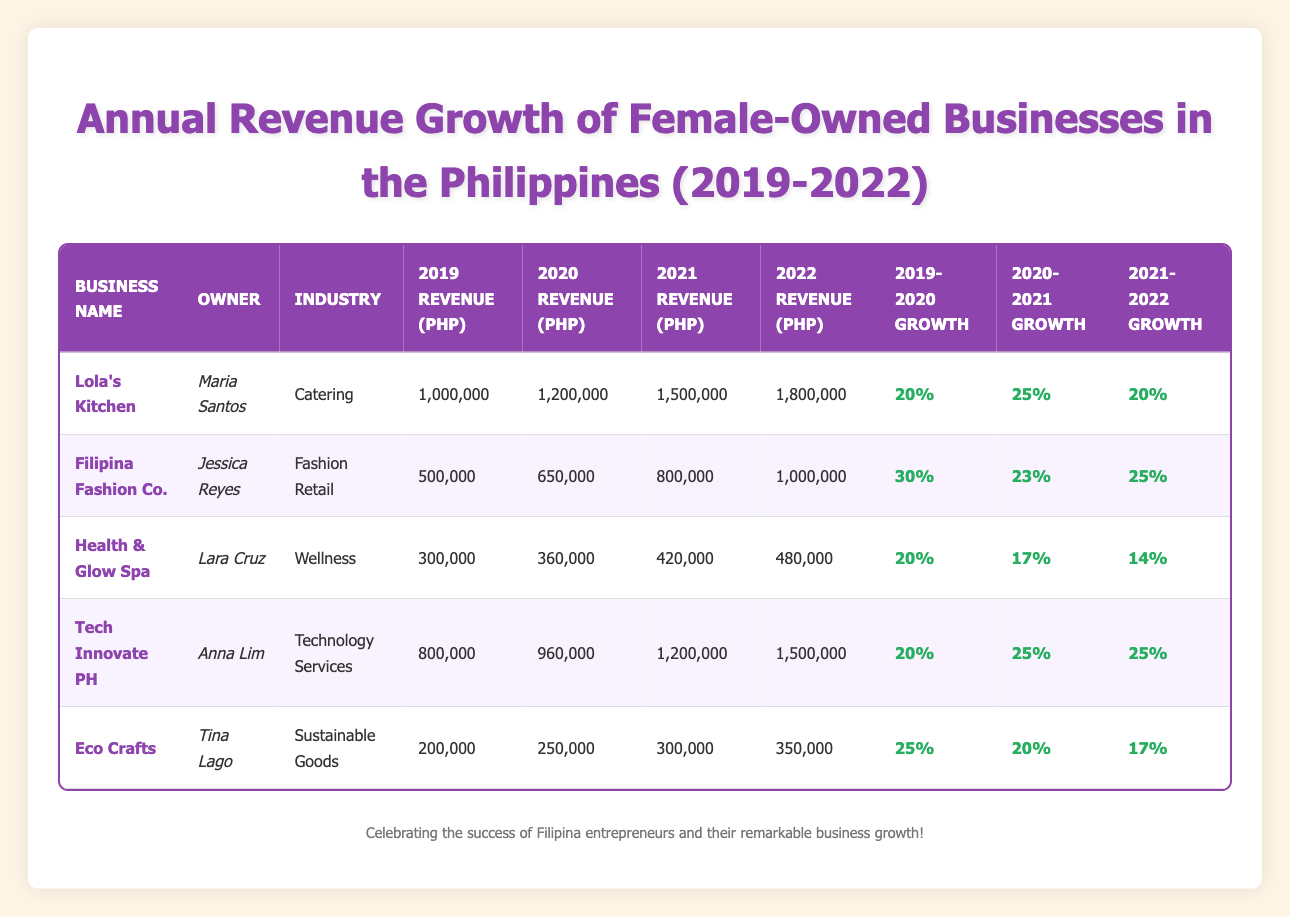What was the revenue of Lola's Kitchen in 2021? From the table, Lola's Kitchen had a revenue of 1,500,000 PHP in 2021.
Answer: 1,500,000 PHP Which business had the highest revenue in 2022? By checking the table, Tech Innovate PH had the highest revenue in 2022 at 1,500,000 PHP, which is the same as Lola's Kitchen.
Answer: Tech Innovate PH and Lola's Kitchen What was the annual growth percentage for Filipina Fashion Co. from 2019 to 2020? Looking at the table, Filipina Fashion Co. had a growth percentage of 30% from 2019 to 2020.
Answer: 30% Which business experienced the lowest growth percentage from 2021 to 2022? Analyzing the growth percentages for that period, Health & Glow Spa had the lowest growth percentage of 14% from 2021 to 2022.
Answer: Health & Glow Spa What was the average revenue for all businesses in 2020? To find the average revenue for 2020, sum the revenues: (1,200,000 + 650,000 + 360,000 + 960,000 + 250,000) = 3,420,000, then divide by 5, yielding an average of 3,420,000 / 5 = 684,000 PHP.
Answer: 684,000 PHP Is it true that Eco Crafts had a higher revenue in 2021 compared to Health & Glow Spa? By looking at the table, Eco Crafts had a revenue of 300,000 PHP in 2021, while Health & Glow Spa had 420,000 PHP, which means Eco Crafts had a lower revenue.
Answer: No What was the total revenue of Tech Innovate PH from 2019 to 2022? The total revenue for Tech Innovate PH is calculated as follows: 800,000 (2019) + 960,000 (2020) + 1,200,000 (2021) + 1,500,000 (2022) = 3,460,000 PHP.
Answer: 3,460,000 PHP Which owner had the highest annual growth percentage from 2019 to 2020? Checking the growth percentages, Jessica Reyes (Filipina Fashion Co.) achieved the highest growth with 30% from 2019 to 2020.
Answer: Jessica Reyes What business showed consistent annual growth percentages throughout the years? Upon reviewing the table, both Lola's Kitchen and Tech Innovate PH maintained consistent growth percentages of 20% and 25%, indicating steady growth across the years analyzed.
Answer: Lola's Kitchen and Tech Innovate PH What was the percentage increase in revenue from 2020 to 2021 for Health & Glow Spa? The growth percentage for Health & Glow Spa from 2020 to 2021 was 17%, as shown in the table.
Answer: 17% 